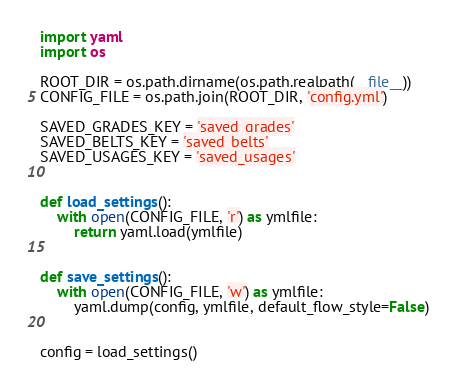<code> <loc_0><loc_0><loc_500><loc_500><_Python_>import yaml
import os

ROOT_DIR = os.path.dirname(os.path.realpath(__file__))
CONFIG_FILE = os.path.join(ROOT_DIR, 'config.yml')

SAVED_GRADES_KEY = 'saved_grades'
SAVED_BELTS_KEY = 'saved_belts'
SAVED_USAGES_KEY = 'saved_usages'


def load_settings():
    with open(CONFIG_FILE, 'r') as ymlfile:
        return yaml.load(ymlfile)


def save_settings():
    with open(CONFIG_FILE, 'w') as ymlfile:
        yaml.dump(config, ymlfile, default_flow_style=False)


config = load_settings()
</code> 